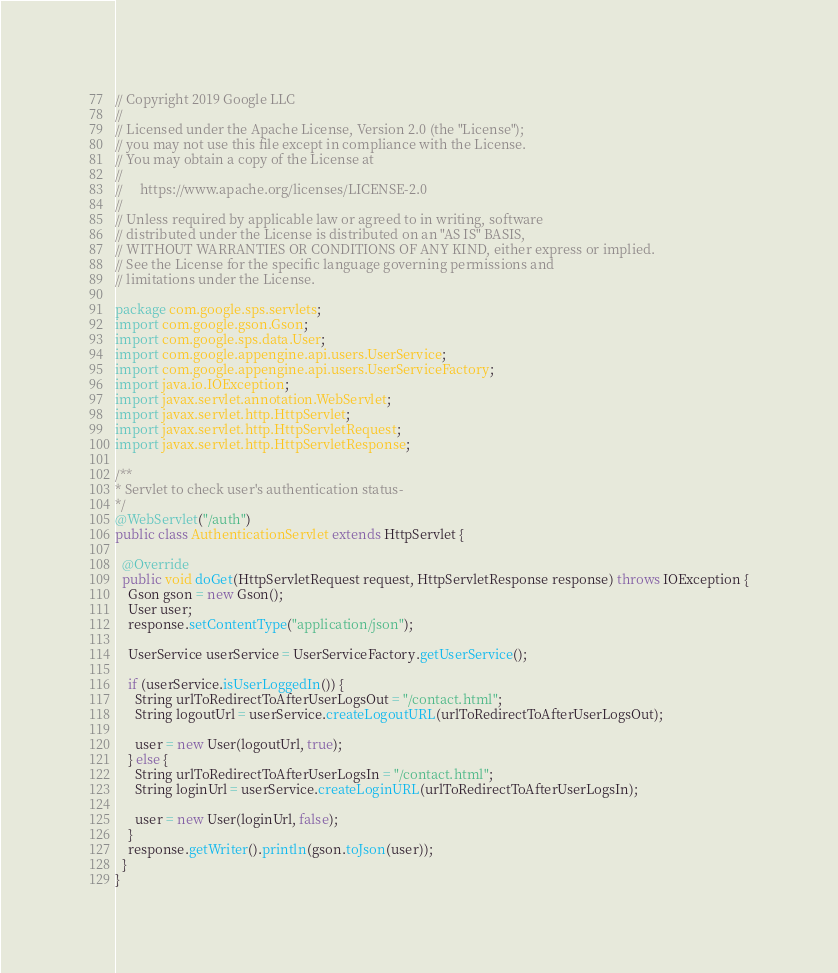Convert code to text. <code><loc_0><loc_0><loc_500><loc_500><_Java_>// Copyright 2019 Google LLC
//
// Licensed under the Apache License, Version 2.0 (the "License");
// you may not use this file except in compliance with the License.
// You may obtain a copy of the License at
//
//     https://www.apache.org/licenses/LICENSE-2.0
//
// Unless required by applicable law or agreed to in writing, software
// distributed under the License is distributed on an "AS IS" BASIS,
// WITHOUT WARRANTIES OR CONDITIONS OF ANY KIND, either express or implied.
// See the License for the specific language governing permissions and
// limitations under the License.

package com.google.sps.servlets;
import com.google.gson.Gson;
import com.google.sps.data.User;
import com.google.appengine.api.users.UserService;
import com.google.appengine.api.users.UserServiceFactory;
import java.io.IOException;
import javax.servlet.annotation.WebServlet;
import javax.servlet.http.HttpServlet;
import javax.servlet.http.HttpServletRequest;
import javax.servlet.http.HttpServletResponse;

/**
* Servlet to check user's authentication status- 
*/
@WebServlet("/auth")
public class AuthenticationServlet extends HttpServlet {

  @Override
  public void doGet(HttpServletRequest request, HttpServletResponse response) throws IOException {
    Gson gson = new Gson();
    User user;
    response.setContentType("application/json");

    UserService userService = UserServiceFactory.getUserService();
    
    if (userService.isUserLoggedIn()) {
      String urlToRedirectToAfterUserLogsOut = "/contact.html";
      String logoutUrl = userService.createLogoutURL(urlToRedirectToAfterUserLogsOut);

      user = new User(logoutUrl, true);
    } else {
      String urlToRedirectToAfterUserLogsIn = "/contact.html";
      String loginUrl = userService.createLoginURL(urlToRedirectToAfterUserLogsIn);

      user = new User(loginUrl, false);
    }
    response.getWriter().println(gson.toJson(user));
  }
}
</code> 